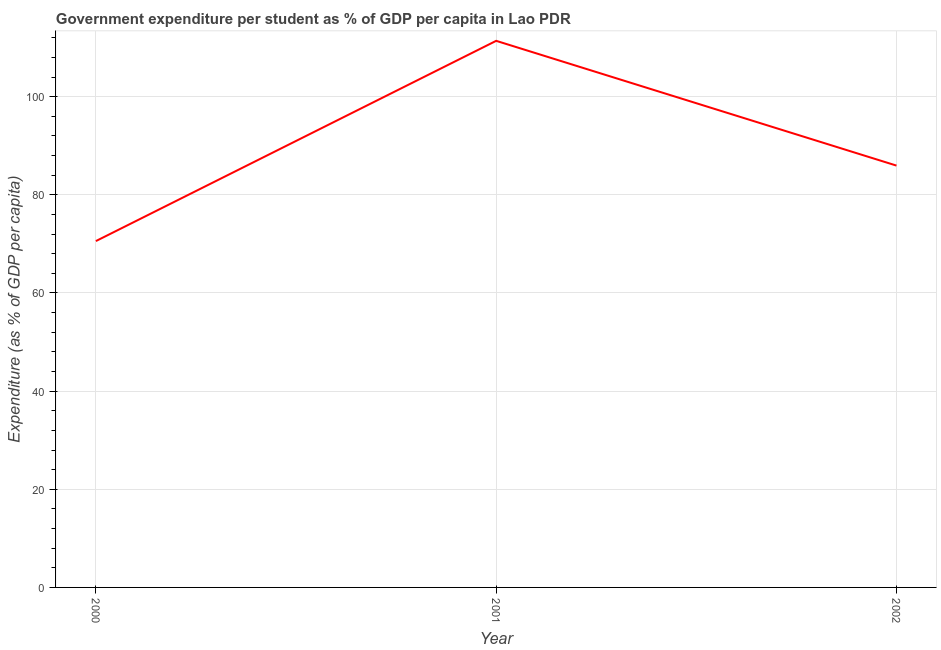What is the government expenditure per student in 2001?
Your answer should be compact. 111.38. Across all years, what is the maximum government expenditure per student?
Give a very brief answer. 111.38. Across all years, what is the minimum government expenditure per student?
Provide a short and direct response. 70.57. In which year was the government expenditure per student maximum?
Provide a short and direct response. 2001. What is the sum of the government expenditure per student?
Keep it short and to the point. 267.91. What is the difference between the government expenditure per student in 2000 and 2001?
Provide a short and direct response. -40.8. What is the average government expenditure per student per year?
Give a very brief answer. 89.3. What is the median government expenditure per student?
Offer a terse response. 85.96. What is the ratio of the government expenditure per student in 2001 to that in 2002?
Ensure brevity in your answer.  1.3. Is the government expenditure per student in 2000 less than that in 2002?
Give a very brief answer. Yes. Is the difference between the government expenditure per student in 2000 and 2002 greater than the difference between any two years?
Your answer should be very brief. No. What is the difference between the highest and the second highest government expenditure per student?
Keep it short and to the point. 25.42. Is the sum of the government expenditure per student in 2001 and 2002 greater than the maximum government expenditure per student across all years?
Provide a short and direct response. Yes. What is the difference between the highest and the lowest government expenditure per student?
Provide a short and direct response. 40.8. In how many years, is the government expenditure per student greater than the average government expenditure per student taken over all years?
Keep it short and to the point. 1. Does the government expenditure per student monotonically increase over the years?
Your answer should be very brief. No. What is the difference between two consecutive major ticks on the Y-axis?
Your response must be concise. 20. Are the values on the major ticks of Y-axis written in scientific E-notation?
Provide a short and direct response. No. Does the graph contain any zero values?
Your answer should be compact. No. What is the title of the graph?
Ensure brevity in your answer.  Government expenditure per student as % of GDP per capita in Lao PDR. What is the label or title of the X-axis?
Keep it short and to the point. Year. What is the label or title of the Y-axis?
Ensure brevity in your answer.  Expenditure (as % of GDP per capita). What is the Expenditure (as % of GDP per capita) in 2000?
Offer a very short reply. 70.57. What is the Expenditure (as % of GDP per capita) in 2001?
Provide a succinct answer. 111.38. What is the Expenditure (as % of GDP per capita) of 2002?
Your response must be concise. 85.96. What is the difference between the Expenditure (as % of GDP per capita) in 2000 and 2001?
Make the answer very short. -40.8. What is the difference between the Expenditure (as % of GDP per capita) in 2000 and 2002?
Your response must be concise. -15.38. What is the difference between the Expenditure (as % of GDP per capita) in 2001 and 2002?
Your response must be concise. 25.42. What is the ratio of the Expenditure (as % of GDP per capita) in 2000 to that in 2001?
Provide a succinct answer. 0.63. What is the ratio of the Expenditure (as % of GDP per capita) in 2000 to that in 2002?
Your answer should be very brief. 0.82. What is the ratio of the Expenditure (as % of GDP per capita) in 2001 to that in 2002?
Ensure brevity in your answer.  1.3. 